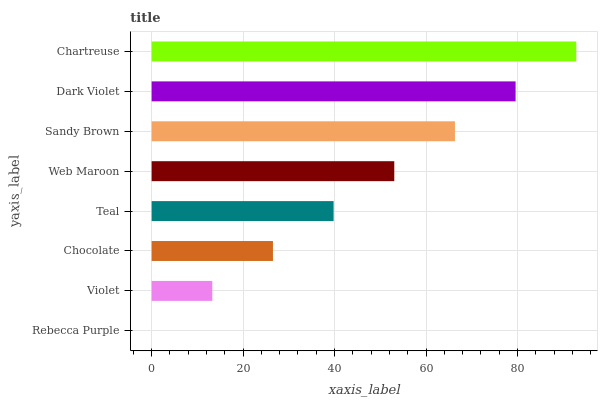Is Rebecca Purple the minimum?
Answer yes or no. Yes. Is Chartreuse the maximum?
Answer yes or no. Yes. Is Violet the minimum?
Answer yes or no. No. Is Violet the maximum?
Answer yes or no. No. Is Violet greater than Rebecca Purple?
Answer yes or no. Yes. Is Rebecca Purple less than Violet?
Answer yes or no. Yes. Is Rebecca Purple greater than Violet?
Answer yes or no. No. Is Violet less than Rebecca Purple?
Answer yes or no. No. Is Web Maroon the high median?
Answer yes or no. Yes. Is Teal the low median?
Answer yes or no. Yes. Is Chartreuse the high median?
Answer yes or no. No. Is Chocolate the low median?
Answer yes or no. No. 